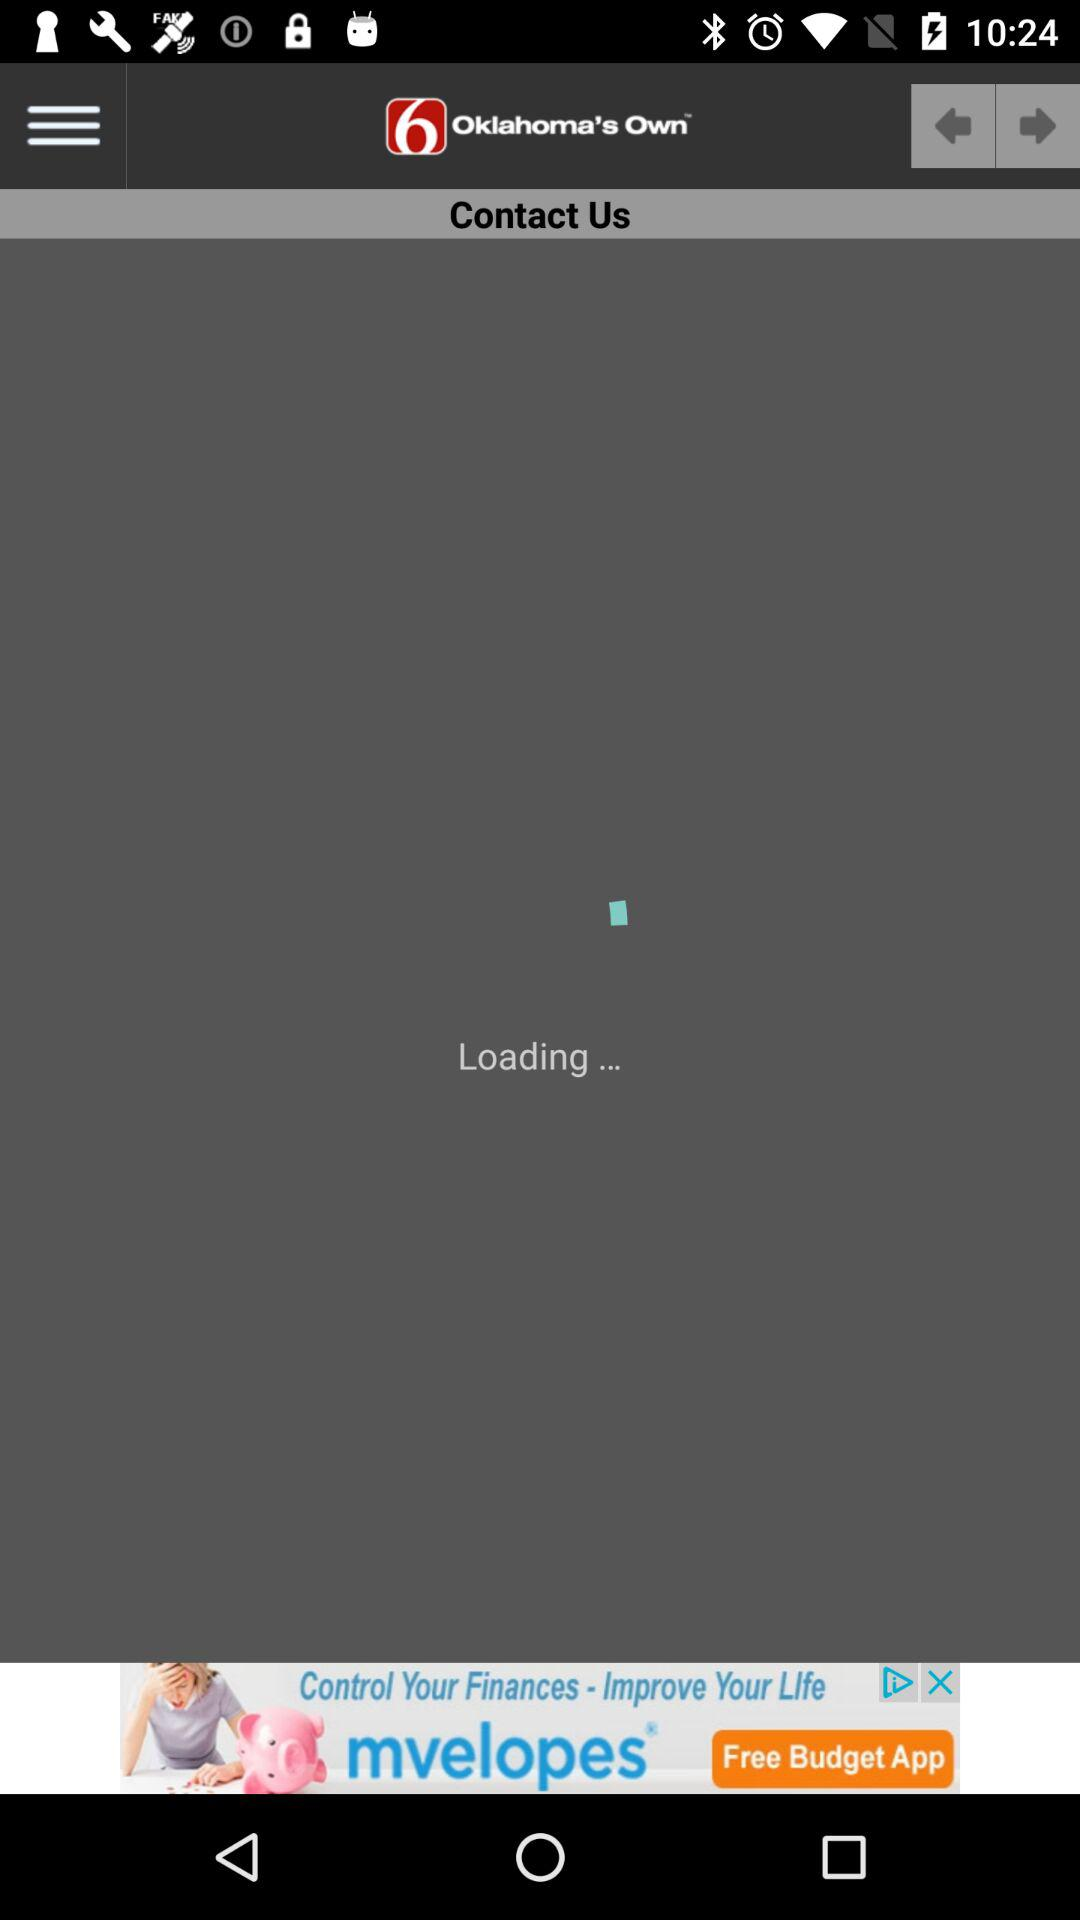When was "Closed Captioning Assistance" published? "Closed Captioning Assistance" was published on September 28, 2012, at 8:12 AM. 